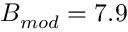Convert formula to latex. <formula><loc_0><loc_0><loc_500><loc_500>B _ { m o d } = 7 . 9</formula> 